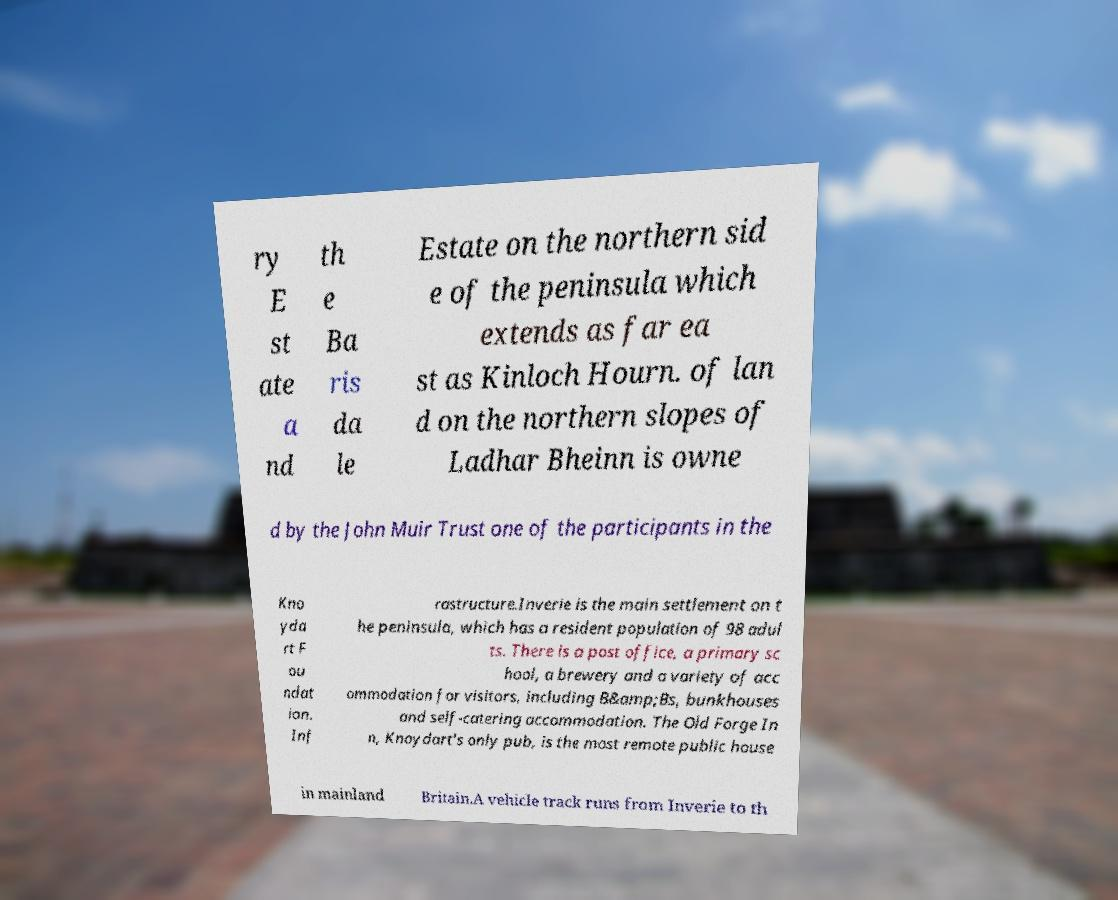Please identify and transcribe the text found in this image. ry E st ate a nd th e Ba ris da le Estate on the northern sid e of the peninsula which extends as far ea st as Kinloch Hourn. of lan d on the northern slopes of Ladhar Bheinn is owne d by the John Muir Trust one of the participants in the Kno yda rt F ou ndat ion. Inf rastructure.Inverie is the main settlement on t he peninsula, which has a resident population of 98 adul ts. There is a post office, a primary sc hool, a brewery and a variety of acc ommodation for visitors, including B&amp;Bs, bunkhouses and self-catering accommodation. The Old Forge In n, Knoydart's only pub, is the most remote public house in mainland Britain.A vehicle track runs from Inverie to th 